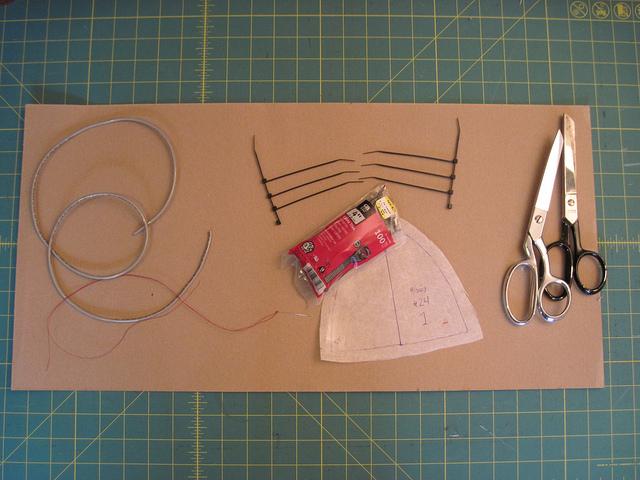How many scissors are on the board?
Write a very short answer. 2. Why is there a graph under the work mat?
Keep it brief. No idea. What are the black objects on the board?
Short answer required. Scissors. 